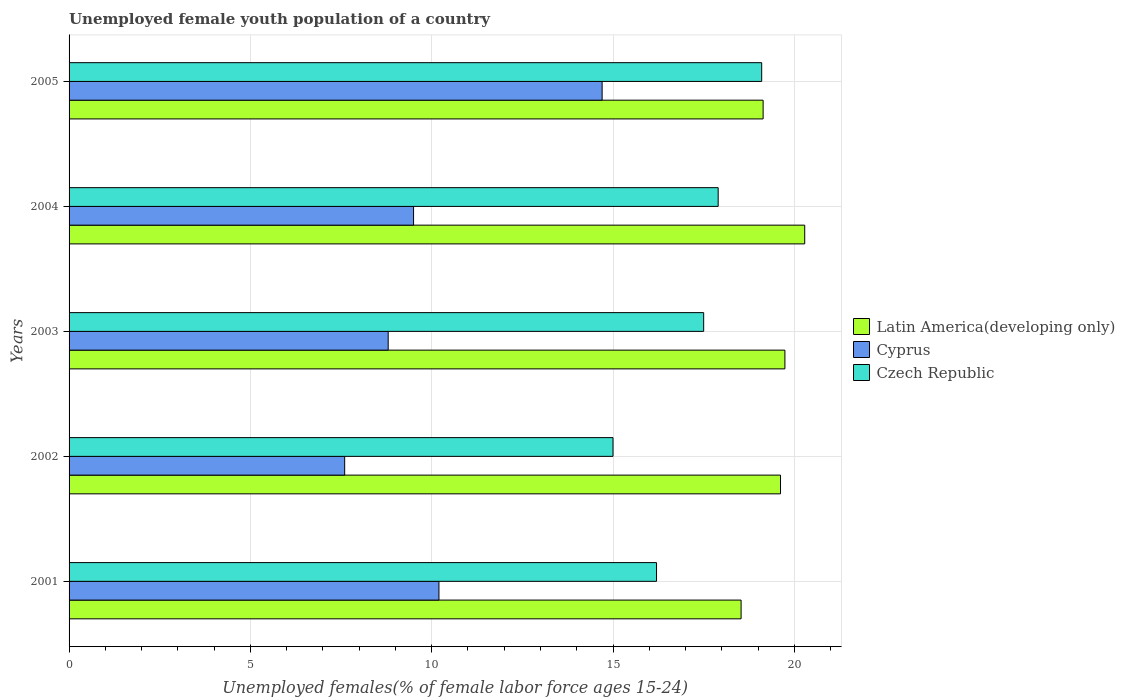How many different coloured bars are there?
Keep it short and to the point. 3. Are the number of bars per tick equal to the number of legend labels?
Keep it short and to the point. Yes. What is the percentage of unemployed female youth population in Cyprus in 2005?
Make the answer very short. 14.7. Across all years, what is the maximum percentage of unemployed female youth population in Latin America(developing only)?
Ensure brevity in your answer.  20.29. Across all years, what is the minimum percentage of unemployed female youth population in Latin America(developing only)?
Provide a short and direct response. 18.53. What is the total percentage of unemployed female youth population in Cyprus in the graph?
Your answer should be very brief. 50.8. What is the difference between the percentage of unemployed female youth population in Latin America(developing only) in 2001 and that in 2003?
Provide a short and direct response. -1.21. What is the difference between the percentage of unemployed female youth population in Czech Republic in 2004 and the percentage of unemployed female youth population in Cyprus in 2001?
Make the answer very short. 7.7. What is the average percentage of unemployed female youth population in Latin America(developing only) per year?
Provide a short and direct response. 19.46. In the year 2002, what is the difference between the percentage of unemployed female youth population in Czech Republic and percentage of unemployed female youth population in Cyprus?
Your response must be concise. 7.4. In how many years, is the percentage of unemployed female youth population in Latin America(developing only) greater than 19 %?
Keep it short and to the point. 4. What is the ratio of the percentage of unemployed female youth population in Cyprus in 2002 to that in 2003?
Your response must be concise. 0.86. Is the percentage of unemployed female youth population in Cyprus in 2001 less than that in 2004?
Offer a terse response. No. Is the difference between the percentage of unemployed female youth population in Czech Republic in 2001 and 2003 greater than the difference between the percentage of unemployed female youth population in Cyprus in 2001 and 2003?
Offer a terse response. No. What is the difference between the highest and the second highest percentage of unemployed female youth population in Czech Republic?
Ensure brevity in your answer.  1.2. What is the difference between the highest and the lowest percentage of unemployed female youth population in Cyprus?
Provide a succinct answer. 7.1. What does the 2nd bar from the top in 2001 represents?
Provide a short and direct response. Cyprus. What does the 2nd bar from the bottom in 2003 represents?
Ensure brevity in your answer.  Cyprus. Are all the bars in the graph horizontal?
Your response must be concise. Yes. What is the difference between two consecutive major ticks on the X-axis?
Make the answer very short. 5. Are the values on the major ticks of X-axis written in scientific E-notation?
Keep it short and to the point. No. Does the graph contain any zero values?
Make the answer very short. No. Where does the legend appear in the graph?
Your answer should be very brief. Center right. How are the legend labels stacked?
Offer a terse response. Vertical. What is the title of the graph?
Your answer should be very brief. Unemployed female youth population of a country. What is the label or title of the X-axis?
Provide a succinct answer. Unemployed females(% of female labor force ages 15-24). What is the label or title of the Y-axis?
Provide a short and direct response. Years. What is the Unemployed females(% of female labor force ages 15-24) in Latin America(developing only) in 2001?
Offer a very short reply. 18.53. What is the Unemployed females(% of female labor force ages 15-24) in Cyprus in 2001?
Your response must be concise. 10.2. What is the Unemployed females(% of female labor force ages 15-24) of Czech Republic in 2001?
Provide a short and direct response. 16.2. What is the Unemployed females(% of female labor force ages 15-24) in Latin America(developing only) in 2002?
Your answer should be very brief. 19.62. What is the Unemployed females(% of female labor force ages 15-24) in Cyprus in 2002?
Provide a succinct answer. 7.6. What is the Unemployed females(% of female labor force ages 15-24) in Latin America(developing only) in 2003?
Ensure brevity in your answer.  19.74. What is the Unemployed females(% of female labor force ages 15-24) in Cyprus in 2003?
Offer a terse response. 8.8. What is the Unemployed females(% of female labor force ages 15-24) in Czech Republic in 2003?
Ensure brevity in your answer.  17.5. What is the Unemployed females(% of female labor force ages 15-24) of Latin America(developing only) in 2004?
Your answer should be very brief. 20.29. What is the Unemployed females(% of female labor force ages 15-24) of Cyprus in 2004?
Give a very brief answer. 9.5. What is the Unemployed females(% of female labor force ages 15-24) in Czech Republic in 2004?
Ensure brevity in your answer.  17.9. What is the Unemployed females(% of female labor force ages 15-24) in Latin America(developing only) in 2005?
Your answer should be compact. 19.14. What is the Unemployed females(% of female labor force ages 15-24) of Cyprus in 2005?
Ensure brevity in your answer.  14.7. What is the Unemployed females(% of female labor force ages 15-24) of Czech Republic in 2005?
Your response must be concise. 19.1. Across all years, what is the maximum Unemployed females(% of female labor force ages 15-24) in Latin America(developing only)?
Ensure brevity in your answer.  20.29. Across all years, what is the maximum Unemployed females(% of female labor force ages 15-24) of Cyprus?
Your response must be concise. 14.7. Across all years, what is the maximum Unemployed females(% of female labor force ages 15-24) of Czech Republic?
Offer a terse response. 19.1. Across all years, what is the minimum Unemployed females(% of female labor force ages 15-24) of Latin America(developing only)?
Offer a terse response. 18.53. Across all years, what is the minimum Unemployed females(% of female labor force ages 15-24) in Cyprus?
Keep it short and to the point. 7.6. Across all years, what is the minimum Unemployed females(% of female labor force ages 15-24) in Czech Republic?
Make the answer very short. 15. What is the total Unemployed females(% of female labor force ages 15-24) in Latin America(developing only) in the graph?
Keep it short and to the point. 97.32. What is the total Unemployed females(% of female labor force ages 15-24) in Cyprus in the graph?
Offer a very short reply. 50.8. What is the total Unemployed females(% of female labor force ages 15-24) of Czech Republic in the graph?
Give a very brief answer. 85.7. What is the difference between the Unemployed females(% of female labor force ages 15-24) in Latin America(developing only) in 2001 and that in 2002?
Make the answer very short. -1.09. What is the difference between the Unemployed females(% of female labor force ages 15-24) of Latin America(developing only) in 2001 and that in 2003?
Provide a short and direct response. -1.21. What is the difference between the Unemployed females(% of female labor force ages 15-24) of Cyprus in 2001 and that in 2003?
Provide a succinct answer. 1.4. What is the difference between the Unemployed females(% of female labor force ages 15-24) of Czech Republic in 2001 and that in 2003?
Give a very brief answer. -1.3. What is the difference between the Unemployed females(% of female labor force ages 15-24) in Latin America(developing only) in 2001 and that in 2004?
Your answer should be compact. -1.75. What is the difference between the Unemployed females(% of female labor force ages 15-24) in Latin America(developing only) in 2001 and that in 2005?
Give a very brief answer. -0.61. What is the difference between the Unemployed females(% of female labor force ages 15-24) in Latin America(developing only) in 2002 and that in 2003?
Provide a short and direct response. -0.12. What is the difference between the Unemployed females(% of female labor force ages 15-24) of Cyprus in 2002 and that in 2003?
Provide a short and direct response. -1.2. What is the difference between the Unemployed females(% of female labor force ages 15-24) in Latin America(developing only) in 2002 and that in 2004?
Ensure brevity in your answer.  -0.67. What is the difference between the Unemployed females(% of female labor force ages 15-24) of Cyprus in 2002 and that in 2004?
Offer a terse response. -1.9. What is the difference between the Unemployed females(% of female labor force ages 15-24) in Latin America(developing only) in 2002 and that in 2005?
Make the answer very short. 0.48. What is the difference between the Unemployed females(% of female labor force ages 15-24) in Latin America(developing only) in 2003 and that in 2004?
Your response must be concise. -0.55. What is the difference between the Unemployed females(% of female labor force ages 15-24) of Cyprus in 2003 and that in 2004?
Provide a short and direct response. -0.7. What is the difference between the Unemployed females(% of female labor force ages 15-24) of Latin America(developing only) in 2003 and that in 2005?
Offer a very short reply. 0.6. What is the difference between the Unemployed females(% of female labor force ages 15-24) in Czech Republic in 2003 and that in 2005?
Offer a very short reply. -1.6. What is the difference between the Unemployed females(% of female labor force ages 15-24) in Latin America(developing only) in 2004 and that in 2005?
Offer a very short reply. 1.15. What is the difference between the Unemployed females(% of female labor force ages 15-24) in Cyprus in 2004 and that in 2005?
Ensure brevity in your answer.  -5.2. What is the difference between the Unemployed females(% of female labor force ages 15-24) of Latin America(developing only) in 2001 and the Unemployed females(% of female labor force ages 15-24) of Cyprus in 2002?
Make the answer very short. 10.93. What is the difference between the Unemployed females(% of female labor force ages 15-24) in Latin America(developing only) in 2001 and the Unemployed females(% of female labor force ages 15-24) in Czech Republic in 2002?
Provide a short and direct response. 3.53. What is the difference between the Unemployed females(% of female labor force ages 15-24) of Cyprus in 2001 and the Unemployed females(% of female labor force ages 15-24) of Czech Republic in 2002?
Provide a succinct answer. -4.8. What is the difference between the Unemployed females(% of female labor force ages 15-24) of Latin America(developing only) in 2001 and the Unemployed females(% of female labor force ages 15-24) of Cyprus in 2003?
Provide a short and direct response. 9.73. What is the difference between the Unemployed females(% of female labor force ages 15-24) of Latin America(developing only) in 2001 and the Unemployed females(% of female labor force ages 15-24) of Czech Republic in 2003?
Keep it short and to the point. 1.03. What is the difference between the Unemployed females(% of female labor force ages 15-24) in Cyprus in 2001 and the Unemployed females(% of female labor force ages 15-24) in Czech Republic in 2003?
Keep it short and to the point. -7.3. What is the difference between the Unemployed females(% of female labor force ages 15-24) in Latin America(developing only) in 2001 and the Unemployed females(% of female labor force ages 15-24) in Cyprus in 2004?
Ensure brevity in your answer.  9.03. What is the difference between the Unemployed females(% of female labor force ages 15-24) in Latin America(developing only) in 2001 and the Unemployed females(% of female labor force ages 15-24) in Czech Republic in 2004?
Keep it short and to the point. 0.63. What is the difference between the Unemployed females(% of female labor force ages 15-24) in Latin America(developing only) in 2001 and the Unemployed females(% of female labor force ages 15-24) in Cyprus in 2005?
Offer a very short reply. 3.83. What is the difference between the Unemployed females(% of female labor force ages 15-24) in Latin America(developing only) in 2001 and the Unemployed females(% of female labor force ages 15-24) in Czech Republic in 2005?
Offer a terse response. -0.57. What is the difference between the Unemployed females(% of female labor force ages 15-24) in Cyprus in 2001 and the Unemployed females(% of female labor force ages 15-24) in Czech Republic in 2005?
Your response must be concise. -8.9. What is the difference between the Unemployed females(% of female labor force ages 15-24) of Latin America(developing only) in 2002 and the Unemployed females(% of female labor force ages 15-24) of Cyprus in 2003?
Your answer should be compact. 10.82. What is the difference between the Unemployed females(% of female labor force ages 15-24) of Latin America(developing only) in 2002 and the Unemployed females(% of female labor force ages 15-24) of Czech Republic in 2003?
Keep it short and to the point. 2.12. What is the difference between the Unemployed females(% of female labor force ages 15-24) in Cyprus in 2002 and the Unemployed females(% of female labor force ages 15-24) in Czech Republic in 2003?
Your answer should be very brief. -9.9. What is the difference between the Unemployed females(% of female labor force ages 15-24) of Latin America(developing only) in 2002 and the Unemployed females(% of female labor force ages 15-24) of Cyprus in 2004?
Your answer should be compact. 10.12. What is the difference between the Unemployed females(% of female labor force ages 15-24) in Latin America(developing only) in 2002 and the Unemployed females(% of female labor force ages 15-24) in Czech Republic in 2004?
Your answer should be very brief. 1.72. What is the difference between the Unemployed females(% of female labor force ages 15-24) in Latin America(developing only) in 2002 and the Unemployed females(% of female labor force ages 15-24) in Cyprus in 2005?
Make the answer very short. 4.92. What is the difference between the Unemployed females(% of female labor force ages 15-24) in Latin America(developing only) in 2002 and the Unemployed females(% of female labor force ages 15-24) in Czech Republic in 2005?
Give a very brief answer. 0.52. What is the difference between the Unemployed females(% of female labor force ages 15-24) of Cyprus in 2002 and the Unemployed females(% of female labor force ages 15-24) of Czech Republic in 2005?
Your response must be concise. -11.5. What is the difference between the Unemployed females(% of female labor force ages 15-24) in Latin America(developing only) in 2003 and the Unemployed females(% of female labor force ages 15-24) in Cyprus in 2004?
Your response must be concise. 10.24. What is the difference between the Unemployed females(% of female labor force ages 15-24) of Latin America(developing only) in 2003 and the Unemployed females(% of female labor force ages 15-24) of Czech Republic in 2004?
Ensure brevity in your answer.  1.84. What is the difference between the Unemployed females(% of female labor force ages 15-24) of Latin America(developing only) in 2003 and the Unemployed females(% of female labor force ages 15-24) of Cyprus in 2005?
Your answer should be compact. 5.04. What is the difference between the Unemployed females(% of female labor force ages 15-24) of Latin America(developing only) in 2003 and the Unemployed females(% of female labor force ages 15-24) of Czech Republic in 2005?
Offer a terse response. 0.64. What is the difference between the Unemployed females(% of female labor force ages 15-24) of Latin America(developing only) in 2004 and the Unemployed females(% of female labor force ages 15-24) of Cyprus in 2005?
Your response must be concise. 5.59. What is the difference between the Unemployed females(% of female labor force ages 15-24) in Latin America(developing only) in 2004 and the Unemployed females(% of female labor force ages 15-24) in Czech Republic in 2005?
Give a very brief answer. 1.19. What is the difference between the Unemployed females(% of female labor force ages 15-24) of Cyprus in 2004 and the Unemployed females(% of female labor force ages 15-24) of Czech Republic in 2005?
Offer a terse response. -9.6. What is the average Unemployed females(% of female labor force ages 15-24) in Latin America(developing only) per year?
Ensure brevity in your answer.  19.46. What is the average Unemployed females(% of female labor force ages 15-24) of Cyprus per year?
Your response must be concise. 10.16. What is the average Unemployed females(% of female labor force ages 15-24) of Czech Republic per year?
Your answer should be very brief. 17.14. In the year 2001, what is the difference between the Unemployed females(% of female labor force ages 15-24) in Latin America(developing only) and Unemployed females(% of female labor force ages 15-24) in Cyprus?
Ensure brevity in your answer.  8.33. In the year 2001, what is the difference between the Unemployed females(% of female labor force ages 15-24) in Latin America(developing only) and Unemployed females(% of female labor force ages 15-24) in Czech Republic?
Make the answer very short. 2.33. In the year 2002, what is the difference between the Unemployed females(% of female labor force ages 15-24) in Latin America(developing only) and Unemployed females(% of female labor force ages 15-24) in Cyprus?
Provide a short and direct response. 12.02. In the year 2002, what is the difference between the Unemployed females(% of female labor force ages 15-24) of Latin America(developing only) and Unemployed females(% of female labor force ages 15-24) of Czech Republic?
Make the answer very short. 4.62. In the year 2003, what is the difference between the Unemployed females(% of female labor force ages 15-24) in Latin America(developing only) and Unemployed females(% of female labor force ages 15-24) in Cyprus?
Provide a succinct answer. 10.94. In the year 2003, what is the difference between the Unemployed females(% of female labor force ages 15-24) in Latin America(developing only) and Unemployed females(% of female labor force ages 15-24) in Czech Republic?
Your response must be concise. 2.24. In the year 2004, what is the difference between the Unemployed females(% of female labor force ages 15-24) in Latin America(developing only) and Unemployed females(% of female labor force ages 15-24) in Cyprus?
Your answer should be very brief. 10.79. In the year 2004, what is the difference between the Unemployed females(% of female labor force ages 15-24) of Latin America(developing only) and Unemployed females(% of female labor force ages 15-24) of Czech Republic?
Your answer should be compact. 2.39. In the year 2004, what is the difference between the Unemployed females(% of female labor force ages 15-24) of Cyprus and Unemployed females(% of female labor force ages 15-24) of Czech Republic?
Offer a very short reply. -8.4. In the year 2005, what is the difference between the Unemployed females(% of female labor force ages 15-24) of Latin America(developing only) and Unemployed females(% of female labor force ages 15-24) of Cyprus?
Give a very brief answer. 4.44. In the year 2005, what is the difference between the Unemployed females(% of female labor force ages 15-24) in Latin America(developing only) and Unemployed females(% of female labor force ages 15-24) in Czech Republic?
Give a very brief answer. 0.04. In the year 2005, what is the difference between the Unemployed females(% of female labor force ages 15-24) of Cyprus and Unemployed females(% of female labor force ages 15-24) of Czech Republic?
Keep it short and to the point. -4.4. What is the ratio of the Unemployed females(% of female labor force ages 15-24) of Latin America(developing only) in 2001 to that in 2002?
Your answer should be very brief. 0.94. What is the ratio of the Unemployed females(% of female labor force ages 15-24) of Cyprus in 2001 to that in 2002?
Make the answer very short. 1.34. What is the ratio of the Unemployed females(% of female labor force ages 15-24) in Latin America(developing only) in 2001 to that in 2003?
Ensure brevity in your answer.  0.94. What is the ratio of the Unemployed females(% of female labor force ages 15-24) in Cyprus in 2001 to that in 2003?
Your answer should be compact. 1.16. What is the ratio of the Unemployed females(% of female labor force ages 15-24) of Czech Republic in 2001 to that in 2003?
Your answer should be very brief. 0.93. What is the ratio of the Unemployed females(% of female labor force ages 15-24) of Latin America(developing only) in 2001 to that in 2004?
Your response must be concise. 0.91. What is the ratio of the Unemployed females(% of female labor force ages 15-24) in Cyprus in 2001 to that in 2004?
Your answer should be compact. 1.07. What is the ratio of the Unemployed females(% of female labor force ages 15-24) in Czech Republic in 2001 to that in 2004?
Provide a succinct answer. 0.91. What is the ratio of the Unemployed females(% of female labor force ages 15-24) of Latin America(developing only) in 2001 to that in 2005?
Give a very brief answer. 0.97. What is the ratio of the Unemployed females(% of female labor force ages 15-24) of Cyprus in 2001 to that in 2005?
Offer a terse response. 0.69. What is the ratio of the Unemployed females(% of female labor force ages 15-24) in Czech Republic in 2001 to that in 2005?
Your answer should be compact. 0.85. What is the ratio of the Unemployed females(% of female labor force ages 15-24) in Cyprus in 2002 to that in 2003?
Keep it short and to the point. 0.86. What is the ratio of the Unemployed females(% of female labor force ages 15-24) of Czech Republic in 2002 to that in 2003?
Offer a very short reply. 0.86. What is the ratio of the Unemployed females(% of female labor force ages 15-24) of Latin America(developing only) in 2002 to that in 2004?
Keep it short and to the point. 0.97. What is the ratio of the Unemployed females(% of female labor force ages 15-24) of Czech Republic in 2002 to that in 2004?
Your answer should be compact. 0.84. What is the ratio of the Unemployed females(% of female labor force ages 15-24) in Latin America(developing only) in 2002 to that in 2005?
Offer a very short reply. 1.03. What is the ratio of the Unemployed females(% of female labor force ages 15-24) of Cyprus in 2002 to that in 2005?
Provide a succinct answer. 0.52. What is the ratio of the Unemployed females(% of female labor force ages 15-24) of Czech Republic in 2002 to that in 2005?
Your answer should be very brief. 0.79. What is the ratio of the Unemployed females(% of female labor force ages 15-24) in Latin America(developing only) in 2003 to that in 2004?
Give a very brief answer. 0.97. What is the ratio of the Unemployed females(% of female labor force ages 15-24) in Cyprus in 2003 to that in 2004?
Give a very brief answer. 0.93. What is the ratio of the Unemployed females(% of female labor force ages 15-24) of Czech Republic in 2003 to that in 2004?
Your answer should be compact. 0.98. What is the ratio of the Unemployed females(% of female labor force ages 15-24) of Latin America(developing only) in 2003 to that in 2005?
Your response must be concise. 1.03. What is the ratio of the Unemployed females(% of female labor force ages 15-24) in Cyprus in 2003 to that in 2005?
Your answer should be very brief. 0.6. What is the ratio of the Unemployed females(% of female labor force ages 15-24) in Czech Republic in 2003 to that in 2005?
Offer a very short reply. 0.92. What is the ratio of the Unemployed females(% of female labor force ages 15-24) in Latin America(developing only) in 2004 to that in 2005?
Provide a short and direct response. 1.06. What is the ratio of the Unemployed females(% of female labor force ages 15-24) in Cyprus in 2004 to that in 2005?
Offer a very short reply. 0.65. What is the ratio of the Unemployed females(% of female labor force ages 15-24) of Czech Republic in 2004 to that in 2005?
Your answer should be compact. 0.94. What is the difference between the highest and the second highest Unemployed females(% of female labor force ages 15-24) in Latin America(developing only)?
Offer a very short reply. 0.55. What is the difference between the highest and the second highest Unemployed females(% of female labor force ages 15-24) in Cyprus?
Provide a succinct answer. 4.5. What is the difference between the highest and the lowest Unemployed females(% of female labor force ages 15-24) of Latin America(developing only)?
Give a very brief answer. 1.75. 